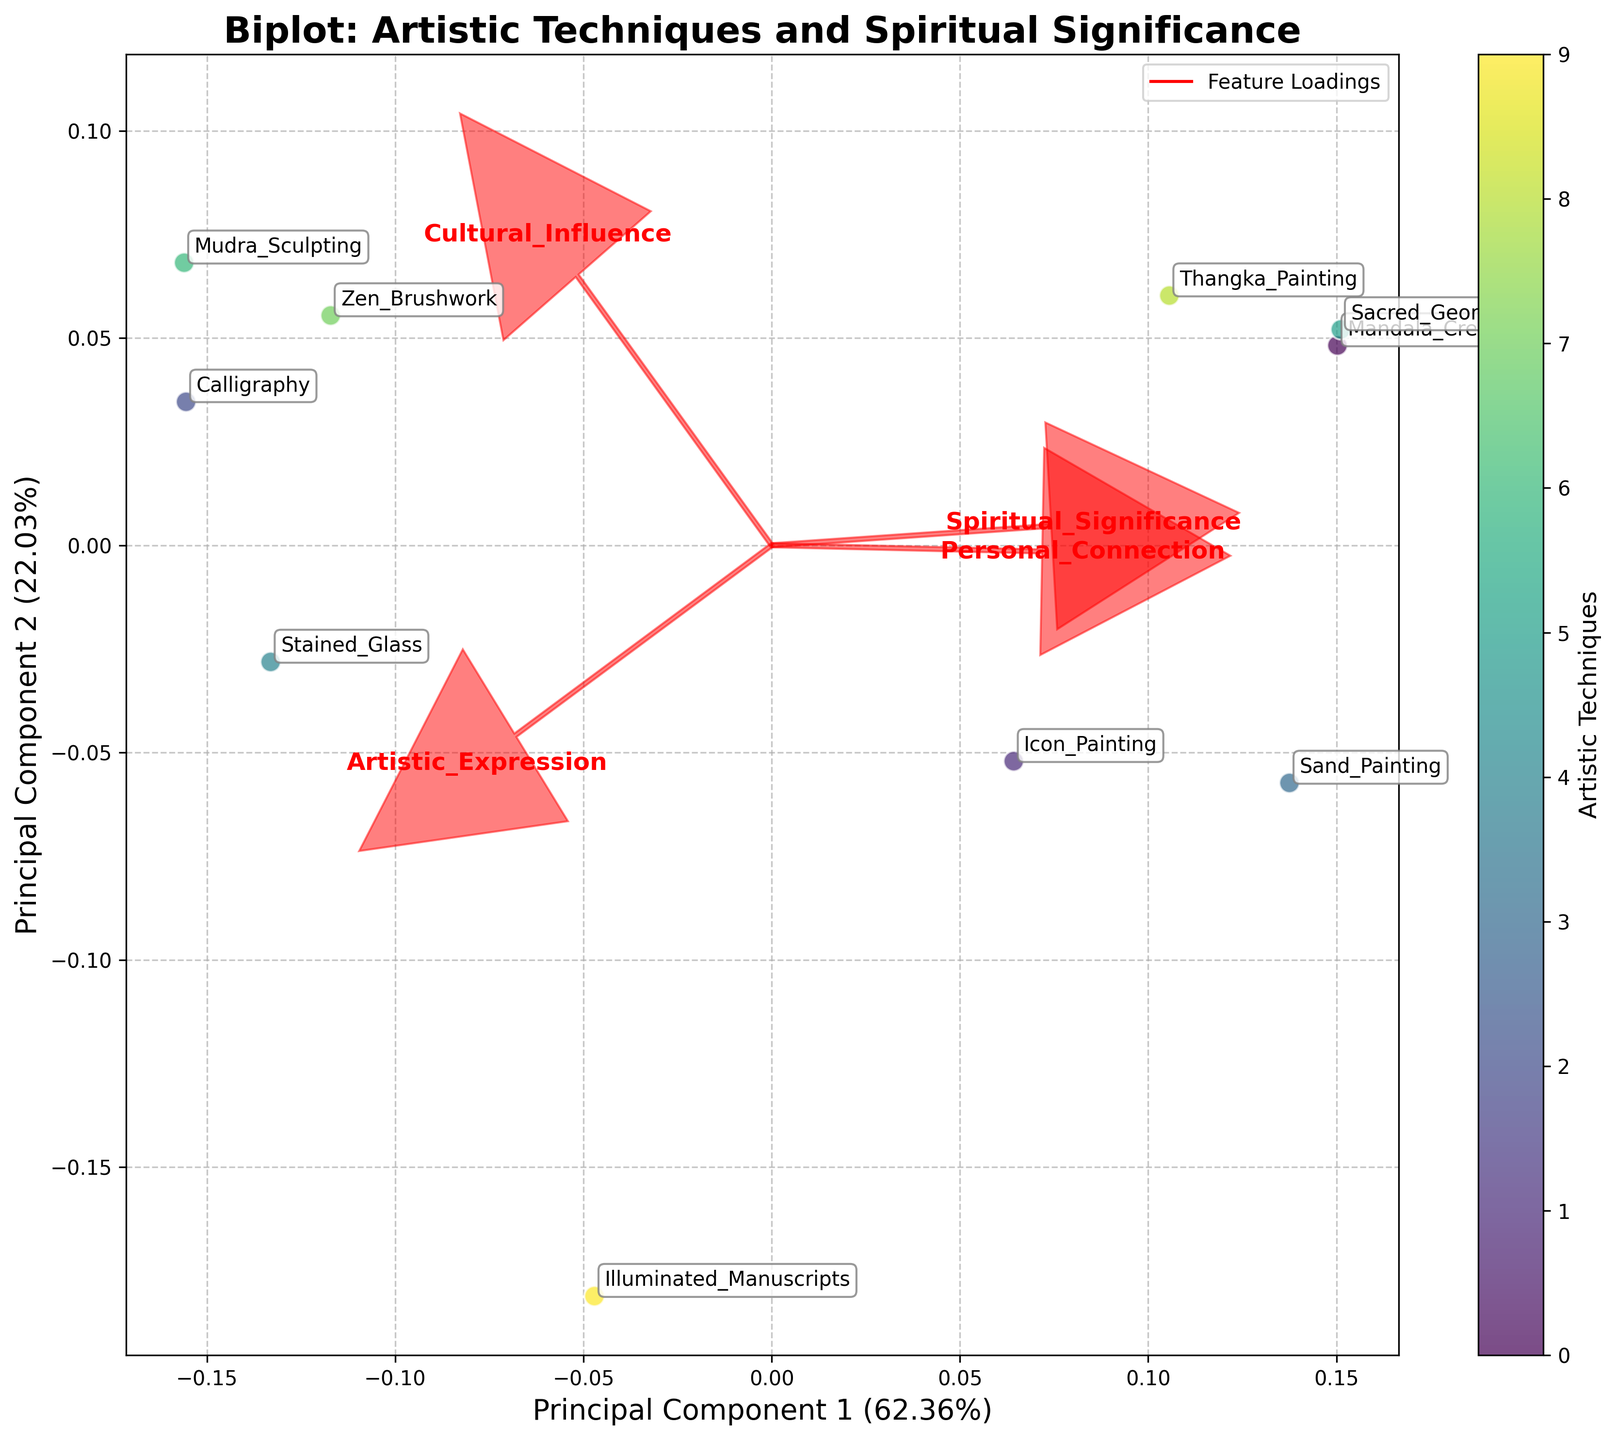What's the title of the figure? The title is usually at the top of the plot and is clearly labeled. Reading the whole title verbatim from the figure gives us the answer.
Answer: Biplot: Artistic Techniques and Spiritual Significance How many artistic techniques are represented in the plot? Each data point represents one artistic technique. By counting the number of data points labeled with different techniques, we can determine the answer.
Answer: 10 Which artistic technique has the highest perceived spiritual significance? We can identify the technique with the highest spiritual significance score by looking at the Principal Component 1 axis, which correlates with this feature. The highest score on this axis indicates the technique.
Answer: Sand Painting Which feature has the largest vector in the biplot? Vectors in a biplot represent the loading vectors of features. By comparing the length of the vectors, we can determine the longest one.
Answer: Artistic Expression What is the approximate explained variance of the first principal component? The explained variance of principal components is usually indicated by the axis labels. Looking at the x-axis label, we can find the percentage.
Answer: ~28% Which two techniques are closest to each other in the biplot? In a biplot, the proximity of points indicates similarity. By identifying the two data points that are nearest to each other in the plot, we can find the answer.
Answer: Icon Painting and Mandala Creation What is the relationship between Calligraphy and Personal Connection? Vectors pointing in the same or opposite direction of a technique can indicate a strong relationship. By evaluating the Personal Connection vector in relation to Calligraphy, we can make this determination.
Answer: Strong relationship What principal component captures more variance? Examining the variances explained by Principal Component 1 and Principal Component 2 (provided in the axis labels), we compare the two values to find the larger one.
Answer: Principal Component 1 Which artistic technique is associated with the highest Cultural Influence? By identifying the position of each technique along the vector corresponding to Cultural Influence, we can determine which technique is at the highest point.
Answer: Zen Brushwork How are Sacred Geometry and Stained Glass positioned relative to each other? We look at the positions of both techniques in the biplot. By observing their relative locations and the lengths of the connecting vectors, we can explain their relationship.
Answer: Sacred Geometry is below and to the left of Stained Glass 